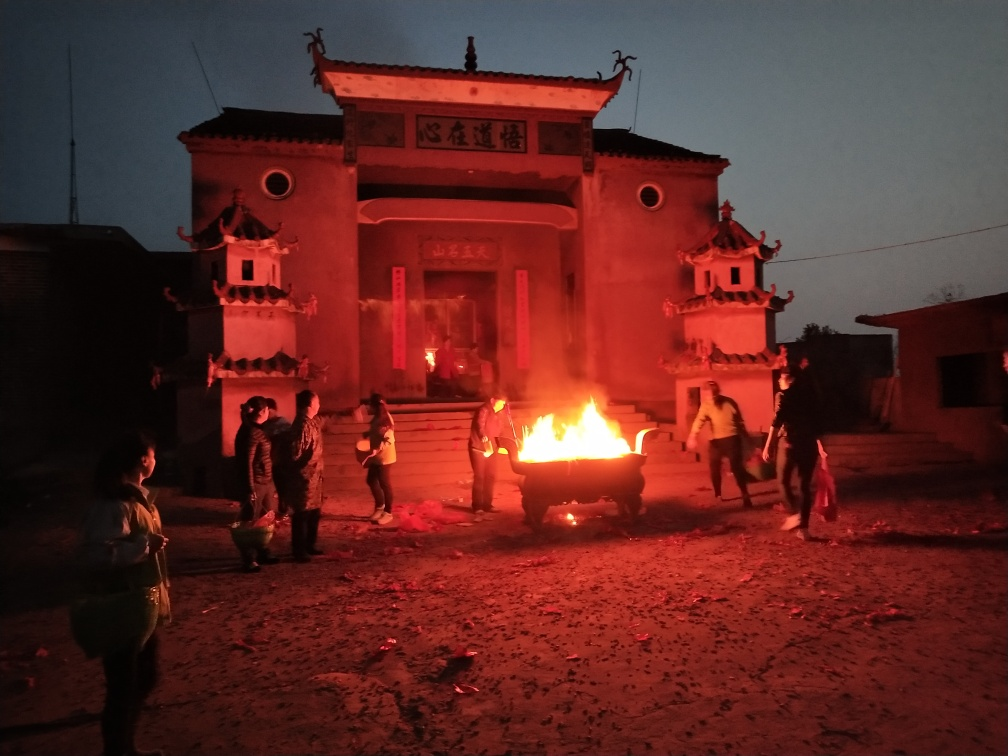Can you describe the atmosphere or mood this image conveys? The image exudes a warm and communal atmosphere. The glow of the fire bathes the scene in a soft, reddish light, casting dynamic shadows and providing a stark contrast to the evening sky. This conveys a sense of intimacy and gathering, hinting at a special event or tradition being observed by the people present. 